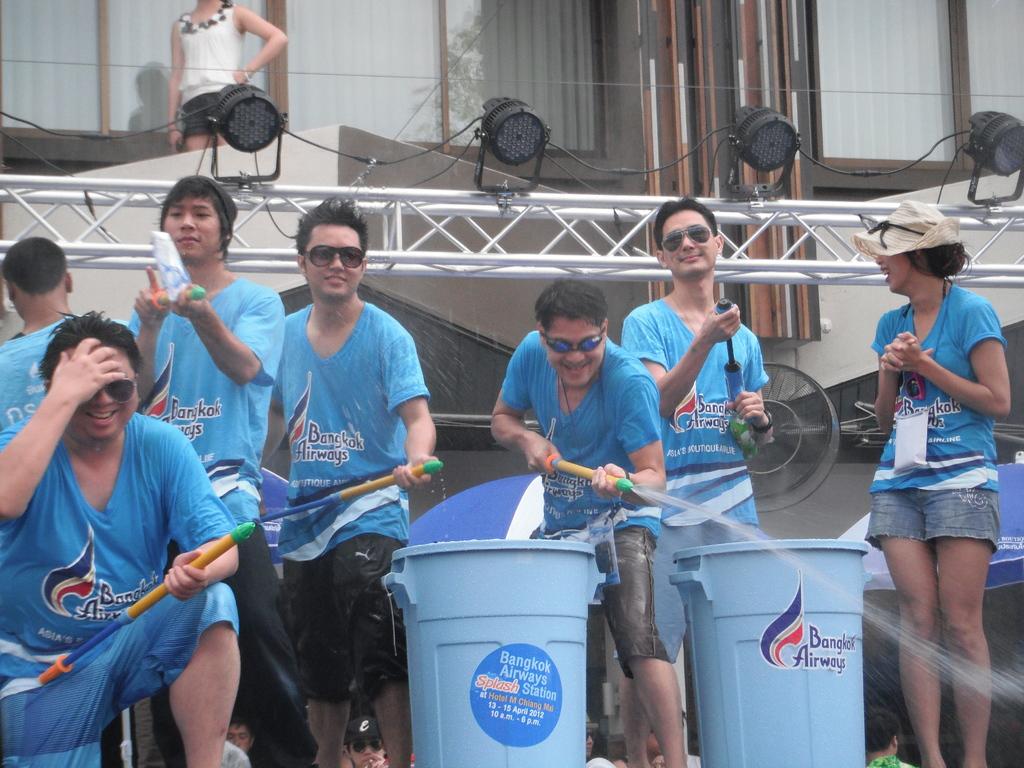What city is this group based in?
Provide a succinct answer. Bangkok. Are these people the airline crew?
Your answer should be compact. Unanswerable. 